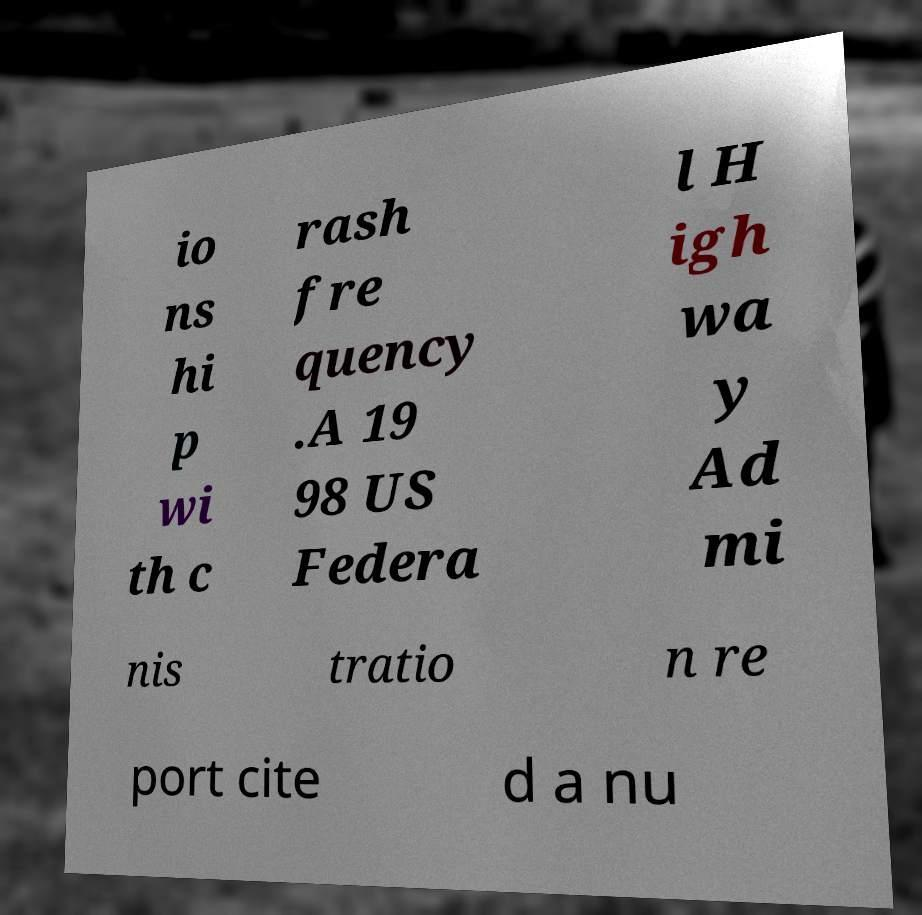I need the written content from this picture converted into text. Can you do that? io ns hi p wi th c rash fre quency .A 19 98 US Federa l H igh wa y Ad mi nis tratio n re port cite d a nu 